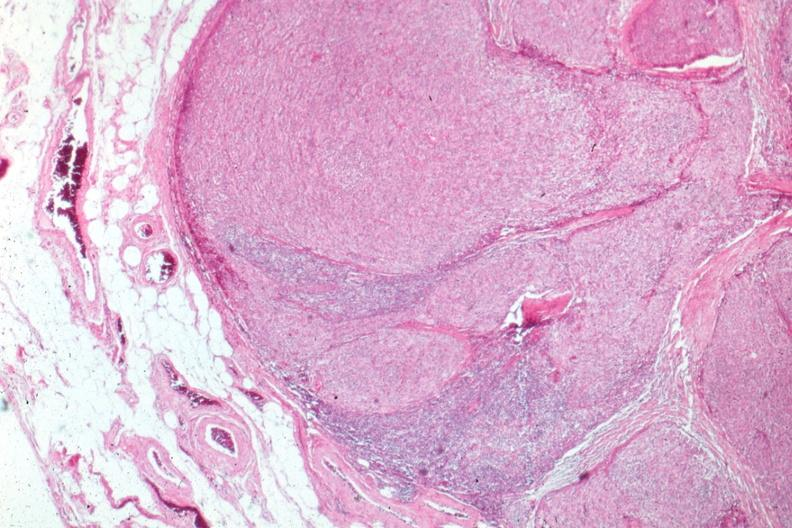s edema present?
Answer the question using a single word or phrase. No 